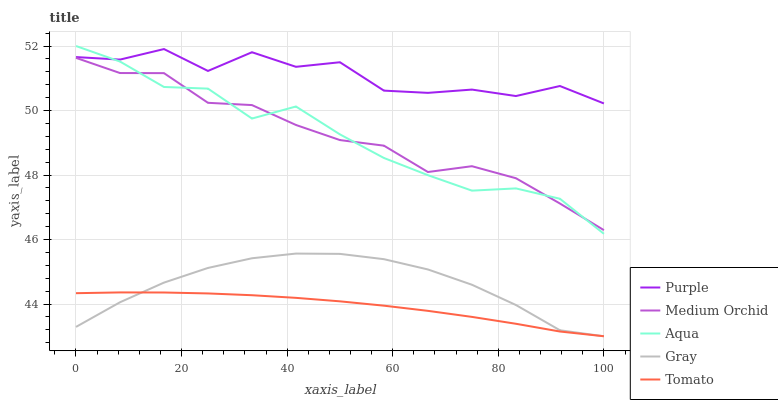Does Gray have the minimum area under the curve?
Answer yes or no. No. Does Gray have the maximum area under the curve?
Answer yes or no. No. Is Gray the smoothest?
Answer yes or no. No. Is Gray the roughest?
Answer yes or no. No. Does Medium Orchid have the lowest value?
Answer yes or no. No. Does Gray have the highest value?
Answer yes or no. No. Is Gray less than Purple?
Answer yes or no. Yes. Is Aqua greater than Tomato?
Answer yes or no. Yes. Does Gray intersect Purple?
Answer yes or no. No. 